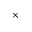Convert formula to latex. <formula><loc_0><loc_0><loc_500><loc_500>\times</formula> 